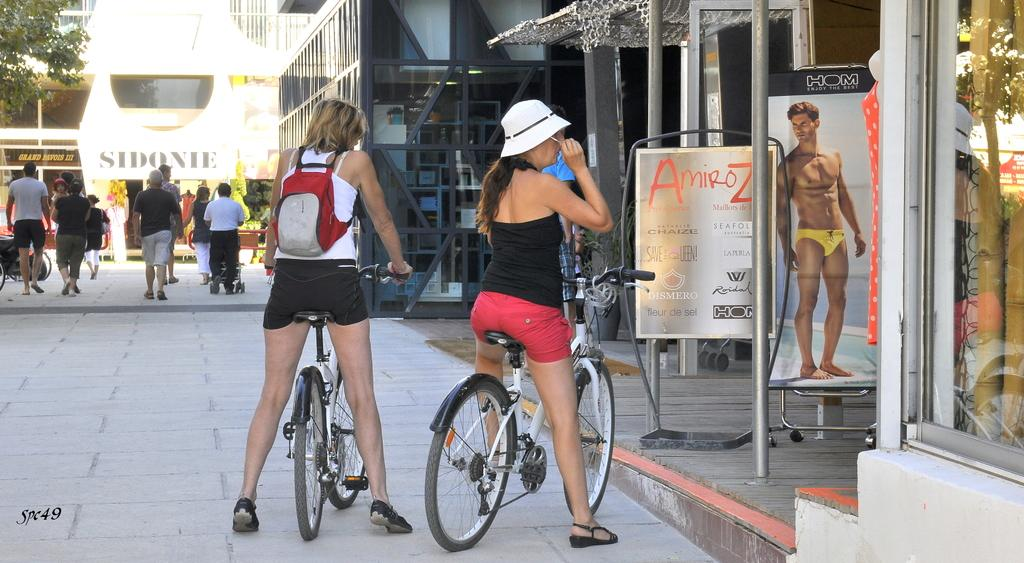What type of structures can be seen in the image? There are buildings in the image. What are the two women on bicycles doing in the image? The two women on bicycles are riding in the image. What is happening in the background of the image? There are people walking in the background of the image. Can you describe the vegetation in the image? There is a tree in the image. What type of commercial establishments are present in the image? There are shops in the image. Are there any advertisements visible in the image? Yes, there are hoardings in the image. What color are the toes of the person walking in the image? There is no information about the color of the toes of the person walking in the image. How much blood is visible in the image? There is no blood visible in the image. 